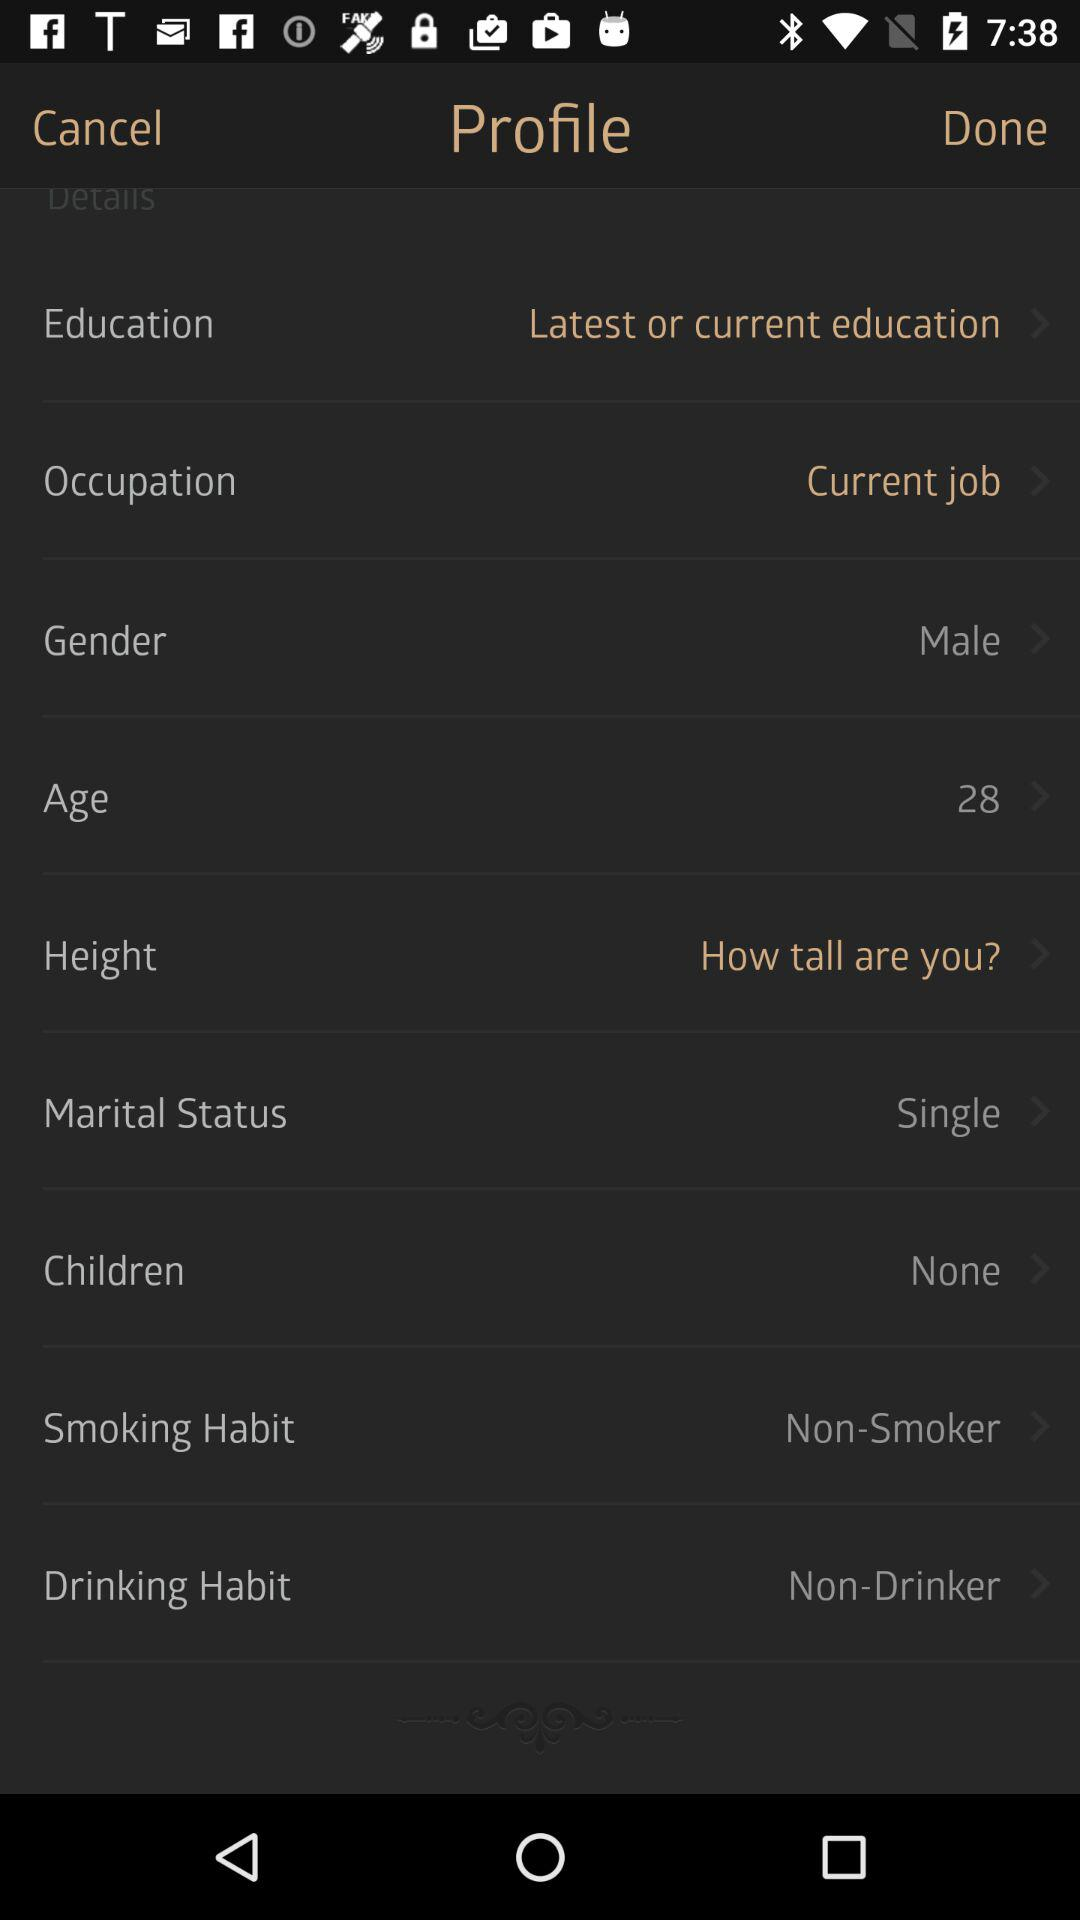What's the age of the person? The age of the person is 28. 